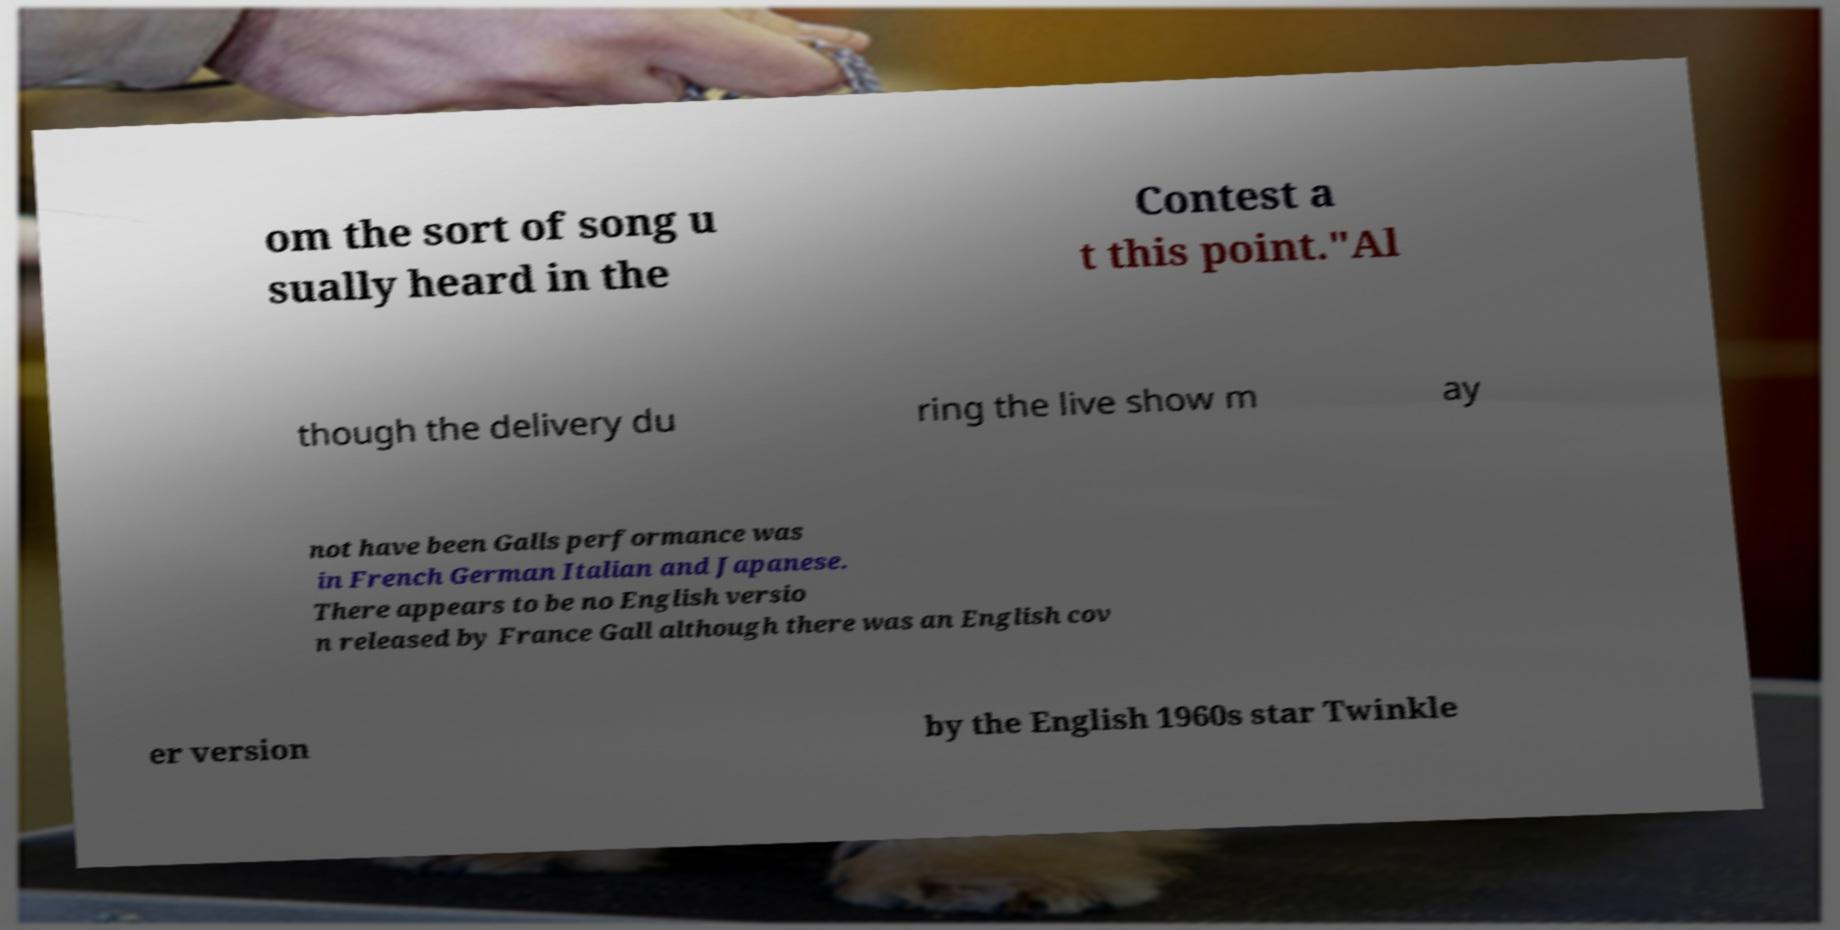Please identify and transcribe the text found in this image. om the sort of song u sually heard in the Contest a t this point."Al though the delivery du ring the live show m ay not have been Galls performance was in French German Italian and Japanese. There appears to be no English versio n released by France Gall although there was an English cov er version by the English 1960s star Twinkle 